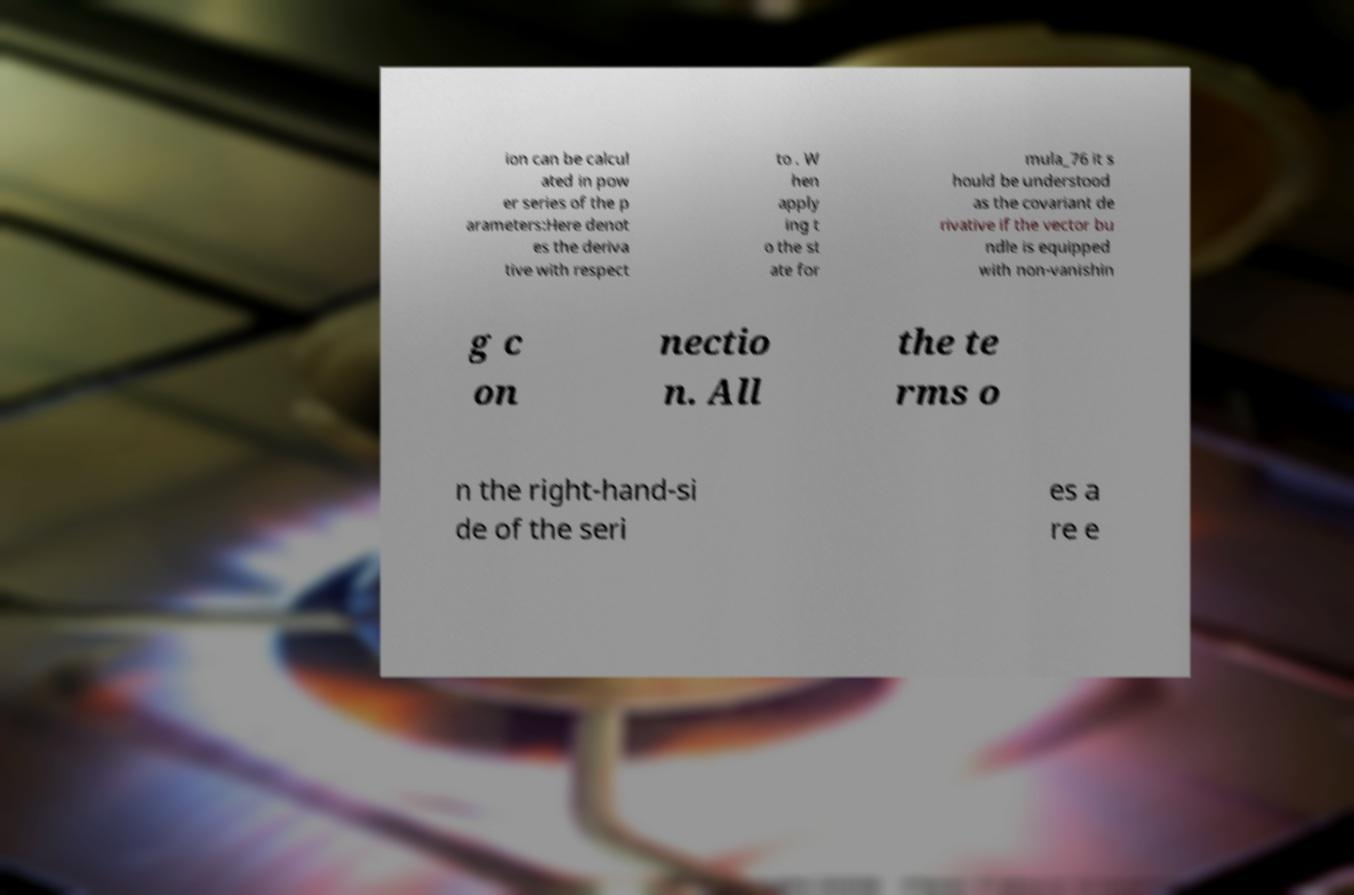Please read and relay the text visible in this image. What does it say? ion can be calcul ated in pow er series of the p arameters:Here denot es the deriva tive with respect to . W hen apply ing t o the st ate for mula_76 it s hould be understood as the covariant de rivative if the vector bu ndle is equipped with non-vanishin g c on nectio n. All the te rms o n the right-hand-si de of the seri es a re e 